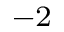Convert formula to latex. <formula><loc_0><loc_0><loc_500><loc_500>^ { - 2 }</formula> 